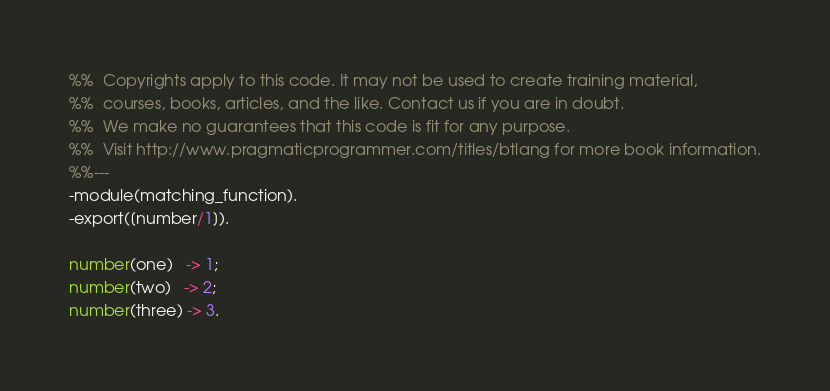Convert code to text. <code><loc_0><loc_0><loc_500><loc_500><_Erlang_>%%  Copyrights apply to this code. It may not be used to create training material, 
%%  courses, books, articles, and the like. Contact us if you are in doubt.
%%  We make no guarantees that this code is fit for any purpose. 
%%  Visit http://www.pragmaticprogrammer.com/titles/btlang for more book information.
%%---
-module(matching_function).
-export([number/1]).

number(one)   -> 1;
number(two)   -> 2; 
number(three) -> 3.</code> 